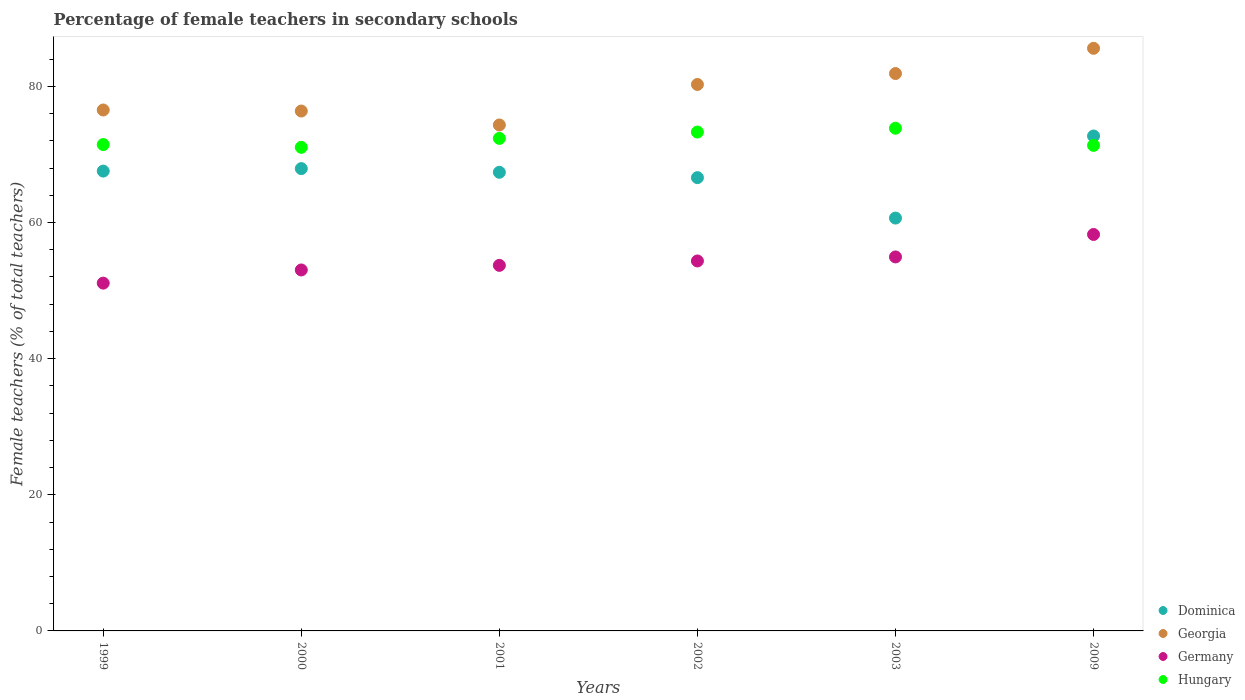How many different coloured dotlines are there?
Your answer should be compact. 4. What is the percentage of female teachers in Dominica in 2003?
Keep it short and to the point. 60.65. Across all years, what is the maximum percentage of female teachers in Germany?
Your answer should be very brief. 58.24. Across all years, what is the minimum percentage of female teachers in Germany?
Give a very brief answer. 51.09. In which year was the percentage of female teachers in Dominica minimum?
Offer a very short reply. 2003. What is the total percentage of female teachers in Germany in the graph?
Your answer should be compact. 325.37. What is the difference between the percentage of female teachers in Dominica in 2000 and that in 2009?
Provide a succinct answer. -4.79. What is the difference between the percentage of female teachers in Dominica in 2000 and the percentage of female teachers in Georgia in 2009?
Make the answer very short. -17.67. What is the average percentage of female teachers in Dominica per year?
Make the answer very short. 67.13. In the year 2001, what is the difference between the percentage of female teachers in Dominica and percentage of female teachers in Germany?
Keep it short and to the point. 13.67. In how many years, is the percentage of female teachers in Hungary greater than 76 %?
Give a very brief answer. 0. What is the ratio of the percentage of female teachers in Georgia in 2002 to that in 2003?
Ensure brevity in your answer.  0.98. What is the difference between the highest and the second highest percentage of female teachers in Georgia?
Provide a short and direct response. 3.71. What is the difference between the highest and the lowest percentage of female teachers in Georgia?
Provide a short and direct response. 11.26. Is the sum of the percentage of female teachers in Georgia in 2000 and 2003 greater than the maximum percentage of female teachers in Germany across all years?
Offer a terse response. Yes. Does the percentage of female teachers in Dominica monotonically increase over the years?
Your answer should be very brief. No. Is the percentage of female teachers in Dominica strictly greater than the percentage of female teachers in Hungary over the years?
Give a very brief answer. No. Is the percentage of female teachers in Hungary strictly less than the percentage of female teachers in Germany over the years?
Make the answer very short. No. What is the difference between two consecutive major ticks on the Y-axis?
Offer a terse response. 20. Are the values on the major ticks of Y-axis written in scientific E-notation?
Your answer should be compact. No. Does the graph contain any zero values?
Provide a succinct answer. No. Does the graph contain grids?
Your answer should be compact. No. What is the title of the graph?
Your answer should be very brief. Percentage of female teachers in secondary schools. What is the label or title of the X-axis?
Keep it short and to the point. Years. What is the label or title of the Y-axis?
Provide a succinct answer. Female teachers (% of total teachers). What is the Female teachers (% of total teachers) in Dominica in 1999?
Provide a succinct answer. 67.55. What is the Female teachers (% of total teachers) in Georgia in 1999?
Your answer should be very brief. 76.53. What is the Female teachers (% of total teachers) of Germany in 1999?
Your answer should be very brief. 51.09. What is the Female teachers (% of total teachers) of Hungary in 1999?
Give a very brief answer. 71.45. What is the Female teachers (% of total teachers) in Dominica in 2000?
Provide a short and direct response. 67.92. What is the Female teachers (% of total teachers) of Georgia in 2000?
Your answer should be compact. 76.38. What is the Female teachers (% of total teachers) of Germany in 2000?
Your answer should be very brief. 53.03. What is the Female teachers (% of total teachers) of Hungary in 2000?
Ensure brevity in your answer.  71.04. What is the Female teachers (% of total teachers) in Dominica in 2001?
Keep it short and to the point. 67.38. What is the Female teachers (% of total teachers) in Georgia in 2001?
Offer a very short reply. 74.33. What is the Female teachers (% of total teachers) of Germany in 2001?
Keep it short and to the point. 53.71. What is the Female teachers (% of total teachers) in Hungary in 2001?
Keep it short and to the point. 72.36. What is the Female teachers (% of total teachers) of Dominica in 2002?
Your answer should be compact. 66.59. What is the Female teachers (% of total teachers) of Georgia in 2002?
Your answer should be compact. 80.28. What is the Female teachers (% of total teachers) in Germany in 2002?
Make the answer very short. 54.35. What is the Female teachers (% of total teachers) of Hungary in 2002?
Your answer should be compact. 73.29. What is the Female teachers (% of total teachers) in Dominica in 2003?
Give a very brief answer. 60.65. What is the Female teachers (% of total teachers) in Georgia in 2003?
Your answer should be very brief. 81.89. What is the Female teachers (% of total teachers) of Germany in 2003?
Provide a short and direct response. 54.94. What is the Female teachers (% of total teachers) of Hungary in 2003?
Offer a terse response. 73.85. What is the Female teachers (% of total teachers) of Dominica in 2009?
Provide a short and direct response. 72.71. What is the Female teachers (% of total teachers) of Georgia in 2009?
Ensure brevity in your answer.  85.59. What is the Female teachers (% of total teachers) in Germany in 2009?
Your response must be concise. 58.24. What is the Female teachers (% of total teachers) in Hungary in 2009?
Make the answer very short. 71.33. Across all years, what is the maximum Female teachers (% of total teachers) in Dominica?
Make the answer very short. 72.71. Across all years, what is the maximum Female teachers (% of total teachers) of Georgia?
Your answer should be very brief. 85.59. Across all years, what is the maximum Female teachers (% of total teachers) of Germany?
Keep it short and to the point. 58.24. Across all years, what is the maximum Female teachers (% of total teachers) in Hungary?
Ensure brevity in your answer.  73.85. Across all years, what is the minimum Female teachers (% of total teachers) in Dominica?
Provide a succinct answer. 60.65. Across all years, what is the minimum Female teachers (% of total teachers) in Georgia?
Offer a very short reply. 74.33. Across all years, what is the minimum Female teachers (% of total teachers) in Germany?
Keep it short and to the point. 51.09. Across all years, what is the minimum Female teachers (% of total teachers) of Hungary?
Ensure brevity in your answer.  71.04. What is the total Female teachers (% of total teachers) in Dominica in the graph?
Provide a succinct answer. 402.81. What is the total Female teachers (% of total teachers) in Georgia in the graph?
Make the answer very short. 475. What is the total Female teachers (% of total teachers) in Germany in the graph?
Your answer should be compact. 325.37. What is the total Female teachers (% of total teachers) of Hungary in the graph?
Offer a terse response. 433.33. What is the difference between the Female teachers (% of total teachers) of Dominica in 1999 and that in 2000?
Offer a very short reply. -0.37. What is the difference between the Female teachers (% of total teachers) in Georgia in 1999 and that in 2000?
Your response must be concise. 0.15. What is the difference between the Female teachers (% of total teachers) of Germany in 1999 and that in 2000?
Keep it short and to the point. -1.93. What is the difference between the Female teachers (% of total teachers) in Hungary in 1999 and that in 2000?
Your response must be concise. 0.41. What is the difference between the Female teachers (% of total teachers) in Dominica in 1999 and that in 2001?
Your response must be concise. 0.17. What is the difference between the Female teachers (% of total teachers) in Georgia in 1999 and that in 2001?
Your answer should be compact. 2.2. What is the difference between the Female teachers (% of total teachers) in Germany in 1999 and that in 2001?
Provide a short and direct response. -2.61. What is the difference between the Female teachers (% of total teachers) of Hungary in 1999 and that in 2001?
Provide a short and direct response. -0.91. What is the difference between the Female teachers (% of total teachers) in Dominica in 1999 and that in 2002?
Your answer should be very brief. 0.96. What is the difference between the Female teachers (% of total teachers) in Georgia in 1999 and that in 2002?
Make the answer very short. -3.75. What is the difference between the Female teachers (% of total teachers) of Germany in 1999 and that in 2002?
Offer a very short reply. -3.26. What is the difference between the Female teachers (% of total teachers) of Hungary in 1999 and that in 2002?
Give a very brief answer. -1.84. What is the difference between the Female teachers (% of total teachers) of Dominica in 1999 and that in 2003?
Your answer should be compact. 6.9. What is the difference between the Female teachers (% of total teachers) of Georgia in 1999 and that in 2003?
Offer a very short reply. -5.35. What is the difference between the Female teachers (% of total teachers) of Germany in 1999 and that in 2003?
Offer a terse response. -3.85. What is the difference between the Female teachers (% of total teachers) of Hungary in 1999 and that in 2003?
Provide a short and direct response. -2.4. What is the difference between the Female teachers (% of total teachers) in Dominica in 1999 and that in 2009?
Ensure brevity in your answer.  -5.16. What is the difference between the Female teachers (% of total teachers) of Georgia in 1999 and that in 2009?
Give a very brief answer. -9.06. What is the difference between the Female teachers (% of total teachers) of Germany in 1999 and that in 2009?
Provide a short and direct response. -7.15. What is the difference between the Female teachers (% of total teachers) of Hungary in 1999 and that in 2009?
Your answer should be compact. 0.12. What is the difference between the Female teachers (% of total teachers) in Dominica in 2000 and that in 2001?
Ensure brevity in your answer.  0.54. What is the difference between the Female teachers (% of total teachers) in Georgia in 2000 and that in 2001?
Your answer should be compact. 2.05. What is the difference between the Female teachers (% of total teachers) in Germany in 2000 and that in 2001?
Make the answer very short. -0.68. What is the difference between the Female teachers (% of total teachers) in Hungary in 2000 and that in 2001?
Provide a succinct answer. -1.31. What is the difference between the Female teachers (% of total teachers) in Dominica in 2000 and that in 2002?
Your answer should be compact. 1.33. What is the difference between the Female teachers (% of total teachers) of Georgia in 2000 and that in 2002?
Make the answer very short. -3.91. What is the difference between the Female teachers (% of total teachers) of Germany in 2000 and that in 2002?
Offer a terse response. -1.32. What is the difference between the Female teachers (% of total teachers) in Hungary in 2000 and that in 2002?
Keep it short and to the point. -2.25. What is the difference between the Female teachers (% of total teachers) in Dominica in 2000 and that in 2003?
Ensure brevity in your answer.  7.27. What is the difference between the Female teachers (% of total teachers) in Georgia in 2000 and that in 2003?
Ensure brevity in your answer.  -5.51. What is the difference between the Female teachers (% of total teachers) in Germany in 2000 and that in 2003?
Offer a very short reply. -1.92. What is the difference between the Female teachers (% of total teachers) of Hungary in 2000 and that in 2003?
Provide a succinct answer. -2.81. What is the difference between the Female teachers (% of total teachers) of Dominica in 2000 and that in 2009?
Offer a very short reply. -4.79. What is the difference between the Female teachers (% of total teachers) of Georgia in 2000 and that in 2009?
Your answer should be very brief. -9.22. What is the difference between the Female teachers (% of total teachers) in Germany in 2000 and that in 2009?
Your answer should be very brief. -5.22. What is the difference between the Female teachers (% of total teachers) of Hungary in 2000 and that in 2009?
Make the answer very short. -0.29. What is the difference between the Female teachers (% of total teachers) in Dominica in 2001 and that in 2002?
Provide a short and direct response. 0.79. What is the difference between the Female teachers (% of total teachers) in Georgia in 2001 and that in 2002?
Offer a terse response. -5.95. What is the difference between the Female teachers (% of total teachers) in Germany in 2001 and that in 2002?
Your answer should be compact. -0.65. What is the difference between the Female teachers (% of total teachers) in Hungary in 2001 and that in 2002?
Provide a short and direct response. -0.93. What is the difference between the Female teachers (% of total teachers) in Dominica in 2001 and that in 2003?
Your answer should be very brief. 6.73. What is the difference between the Female teachers (% of total teachers) of Georgia in 2001 and that in 2003?
Offer a terse response. -7.55. What is the difference between the Female teachers (% of total teachers) of Germany in 2001 and that in 2003?
Offer a terse response. -1.24. What is the difference between the Female teachers (% of total teachers) in Hungary in 2001 and that in 2003?
Make the answer very short. -1.49. What is the difference between the Female teachers (% of total teachers) in Dominica in 2001 and that in 2009?
Provide a succinct answer. -5.33. What is the difference between the Female teachers (% of total teachers) in Georgia in 2001 and that in 2009?
Offer a very short reply. -11.26. What is the difference between the Female teachers (% of total teachers) of Germany in 2001 and that in 2009?
Keep it short and to the point. -4.54. What is the difference between the Female teachers (% of total teachers) in Hungary in 2001 and that in 2009?
Your answer should be compact. 1.03. What is the difference between the Female teachers (% of total teachers) of Dominica in 2002 and that in 2003?
Make the answer very short. 5.94. What is the difference between the Female teachers (% of total teachers) of Georgia in 2002 and that in 2003?
Provide a short and direct response. -1.6. What is the difference between the Female teachers (% of total teachers) of Germany in 2002 and that in 2003?
Provide a succinct answer. -0.59. What is the difference between the Female teachers (% of total teachers) in Hungary in 2002 and that in 2003?
Your response must be concise. -0.56. What is the difference between the Female teachers (% of total teachers) of Dominica in 2002 and that in 2009?
Ensure brevity in your answer.  -6.12. What is the difference between the Female teachers (% of total teachers) of Georgia in 2002 and that in 2009?
Ensure brevity in your answer.  -5.31. What is the difference between the Female teachers (% of total teachers) in Germany in 2002 and that in 2009?
Keep it short and to the point. -3.89. What is the difference between the Female teachers (% of total teachers) of Hungary in 2002 and that in 2009?
Your answer should be very brief. 1.96. What is the difference between the Female teachers (% of total teachers) in Dominica in 2003 and that in 2009?
Offer a very short reply. -12.06. What is the difference between the Female teachers (% of total teachers) of Georgia in 2003 and that in 2009?
Provide a succinct answer. -3.71. What is the difference between the Female teachers (% of total teachers) of Germany in 2003 and that in 2009?
Make the answer very short. -3.3. What is the difference between the Female teachers (% of total teachers) in Hungary in 2003 and that in 2009?
Offer a very short reply. 2.52. What is the difference between the Female teachers (% of total teachers) of Dominica in 1999 and the Female teachers (% of total teachers) of Georgia in 2000?
Offer a terse response. -8.82. What is the difference between the Female teachers (% of total teachers) in Dominica in 1999 and the Female teachers (% of total teachers) in Germany in 2000?
Make the answer very short. 14.52. What is the difference between the Female teachers (% of total teachers) in Dominica in 1999 and the Female teachers (% of total teachers) in Hungary in 2000?
Provide a succinct answer. -3.49. What is the difference between the Female teachers (% of total teachers) of Georgia in 1999 and the Female teachers (% of total teachers) of Germany in 2000?
Your response must be concise. 23.5. What is the difference between the Female teachers (% of total teachers) of Georgia in 1999 and the Female teachers (% of total teachers) of Hungary in 2000?
Provide a succinct answer. 5.49. What is the difference between the Female teachers (% of total teachers) of Germany in 1999 and the Female teachers (% of total teachers) of Hungary in 2000?
Keep it short and to the point. -19.95. What is the difference between the Female teachers (% of total teachers) in Dominica in 1999 and the Female teachers (% of total teachers) in Georgia in 2001?
Your response must be concise. -6.78. What is the difference between the Female teachers (% of total teachers) of Dominica in 1999 and the Female teachers (% of total teachers) of Germany in 2001?
Offer a very short reply. 13.85. What is the difference between the Female teachers (% of total teachers) of Dominica in 1999 and the Female teachers (% of total teachers) of Hungary in 2001?
Offer a very short reply. -4.81. What is the difference between the Female teachers (% of total teachers) of Georgia in 1999 and the Female teachers (% of total teachers) of Germany in 2001?
Your answer should be very brief. 22.83. What is the difference between the Female teachers (% of total teachers) in Georgia in 1999 and the Female teachers (% of total teachers) in Hungary in 2001?
Give a very brief answer. 4.17. What is the difference between the Female teachers (% of total teachers) in Germany in 1999 and the Female teachers (% of total teachers) in Hungary in 2001?
Ensure brevity in your answer.  -21.26. What is the difference between the Female teachers (% of total teachers) of Dominica in 1999 and the Female teachers (% of total teachers) of Georgia in 2002?
Your answer should be very brief. -12.73. What is the difference between the Female teachers (% of total teachers) of Dominica in 1999 and the Female teachers (% of total teachers) of Germany in 2002?
Provide a short and direct response. 13.2. What is the difference between the Female teachers (% of total teachers) of Dominica in 1999 and the Female teachers (% of total teachers) of Hungary in 2002?
Provide a short and direct response. -5.74. What is the difference between the Female teachers (% of total teachers) of Georgia in 1999 and the Female teachers (% of total teachers) of Germany in 2002?
Offer a very short reply. 22.18. What is the difference between the Female teachers (% of total teachers) of Georgia in 1999 and the Female teachers (% of total teachers) of Hungary in 2002?
Give a very brief answer. 3.24. What is the difference between the Female teachers (% of total teachers) in Germany in 1999 and the Female teachers (% of total teachers) in Hungary in 2002?
Your response must be concise. -22.19. What is the difference between the Female teachers (% of total teachers) in Dominica in 1999 and the Female teachers (% of total teachers) in Georgia in 2003?
Offer a very short reply. -14.33. What is the difference between the Female teachers (% of total teachers) in Dominica in 1999 and the Female teachers (% of total teachers) in Germany in 2003?
Provide a short and direct response. 12.61. What is the difference between the Female teachers (% of total teachers) of Dominica in 1999 and the Female teachers (% of total teachers) of Hungary in 2003?
Offer a terse response. -6.3. What is the difference between the Female teachers (% of total teachers) of Georgia in 1999 and the Female teachers (% of total teachers) of Germany in 2003?
Make the answer very short. 21.59. What is the difference between the Female teachers (% of total teachers) in Georgia in 1999 and the Female teachers (% of total teachers) in Hungary in 2003?
Provide a succinct answer. 2.68. What is the difference between the Female teachers (% of total teachers) of Germany in 1999 and the Female teachers (% of total teachers) of Hungary in 2003?
Offer a terse response. -22.76. What is the difference between the Female teachers (% of total teachers) in Dominica in 1999 and the Female teachers (% of total teachers) in Georgia in 2009?
Keep it short and to the point. -18.04. What is the difference between the Female teachers (% of total teachers) of Dominica in 1999 and the Female teachers (% of total teachers) of Germany in 2009?
Offer a terse response. 9.31. What is the difference between the Female teachers (% of total teachers) in Dominica in 1999 and the Female teachers (% of total teachers) in Hungary in 2009?
Give a very brief answer. -3.78. What is the difference between the Female teachers (% of total teachers) of Georgia in 1999 and the Female teachers (% of total teachers) of Germany in 2009?
Give a very brief answer. 18.29. What is the difference between the Female teachers (% of total teachers) of Georgia in 1999 and the Female teachers (% of total teachers) of Hungary in 2009?
Offer a very short reply. 5.2. What is the difference between the Female teachers (% of total teachers) in Germany in 1999 and the Female teachers (% of total teachers) in Hungary in 2009?
Ensure brevity in your answer.  -20.24. What is the difference between the Female teachers (% of total teachers) in Dominica in 2000 and the Female teachers (% of total teachers) in Georgia in 2001?
Offer a very short reply. -6.41. What is the difference between the Female teachers (% of total teachers) in Dominica in 2000 and the Female teachers (% of total teachers) in Germany in 2001?
Your answer should be very brief. 14.21. What is the difference between the Female teachers (% of total teachers) of Dominica in 2000 and the Female teachers (% of total teachers) of Hungary in 2001?
Provide a short and direct response. -4.44. What is the difference between the Female teachers (% of total teachers) in Georgia in 2000 and the Female teachers (% of total teachers) in Germany in 2001?
Keep it short and to the point. 22.67. What is the difference between the Female teachers (% of total teachers) of Georgia in 2000 and the Female teachers (% of total teachers) of Hungary in 2001?
Provide a short and direct response. 4.02. What is the difference between the Female teachers (% of total teachers) of Germany in 2000 and the Female teachers (% of total teachers) of Hungary in 2001?
Keep it short and to the point. -19.33. What is the difference between the Female teachers (% of total teachers) of Dominica in 2000 and the Female teachers (% of total teachers) of Georgia in 2002?
Make the answer very short. -12.36. What is the difference between the Female teachers (% of total teachers) in Dominica in 2000 and the Female teachers (% of total teachers) in Germany in 2002?
Provide a succinct answer. 13.57. What is the difference between the Female teachers (% of total teachers) in Dominica in 2000 and the Female teachers (% of total teachers) in Hungary in 2002?
Make the answer very short. -5.37. What is the difference between the Female teachers (% of total teachers) in Georgia in 2000 and the Female teachers (% of total teachers) in Germany in 2002?
Give a very brief answer. 22.02. What is the difference between the Female teachers (% of total teachers) of Georgia in 2000 and the Female teachers (% of total teachers) of Hungary in 2002?
Provide a short and direct response. 3.09. What is the difference between the Female teachers (% of total teachers) of Germany in 2000 and the Female teachers (% of total teachers) of Hungary in 2002?
Offer a very short reply. -20.26. What is the difference between the Female teachers (% of total teachers) in Dominica in 2000 and the Female teachers (% of total teachers) in Georgia in 2003?
Provide a succinct answer. -13.97. What is the difference between the Female teachers (% of total teachers) in Dominica in 2000 and the Female teachers (% of total teachers) in Germany in 2003?
Offer a terse response. 12.97. What is the difference between the Female teachers (% of total teachers) of Dominica in 2000 and the Female teachers (% of total teachers) of Hungary in 2003?
Your answer should be compact. -5.93. What is the difference between the Female teachers (% of total teachers) in Georgia in 2000 and the Female teachers (% of total teachers) in Germany in 2003?
Offer a very short reply. 21.43. What is the difference between the Female teachers (% of total teachers) of Georgia in 2000 and the Female teachers (% of total teachers) of Hungary in 2003?
Your answer should be compact. 2.53. What is the difference between the Female teachers (% of total teachers) of Germany in 2000 and the Female teachers (% of total teachers) of Hungary in 2003?
Your response must be concise. -20.82. What is the difference between the Female teachers (% of total teachers) in Dominica in 2000 and the Female teachers (% of total teachers) in Georgia in 2009?
Your answer should be compact. -17.67. What is the difference between the Female teachers (% of total teachers) in Dominica in 2000 and the Female teachers (% of total teachers) in Germany in 2009?
Your answer should be very brief. 9.68. What is the difference between the Female teachers (% of total teachers) of Dominica in 2000 and the Female teachers (% of total teachers) of Hungary in 2009?
Give a very brief answer. -3.41. What is the difference between the Female teachers (% of total teachers) in Georgia in 2000 and the Female teachers (% of total teachers) in Germany in 2009?
Give a very brief answer. 18.13. What is the difference between the Female teachers (% of total teachers) in Georgia in 2000 and the Female teachers (% of total teachers) in Hungary in 2009?
Provide a short and direct response. 5.05. What is the difference between the Female teachers (% of total teachers) of Germany in 2000 and the Female teachers (% of total teachers) of Hungary in 2009?
Provide a succinct answer. -18.3. What is the difference between the Female teachers (% of total teachers) in Dominica in 2001 and the Female teachers (% of total teachers) in Georgia in 2002?
Give a very brief answer. -12.9. What is the difference between the Female teachers (% of total teachers) in Dominica in 2001 and the Female teachers (% of total teachers) in Germany in 2002?
Provide a succinct answer. 13.03. What is the difference between the Female teachers (% of total teachers) in Dominica in 2001 and the Female teachers (% of total teachers) in Hungary in 2002?
Keep it short and to the point. -5.91. What is the difference between the Female teachers (% of total teachers) in Georgia in 2001 and the Female teachers (% of total teachers) in Germany in 2002?
Provide a short and direct response. 19.98. What is the difference between the Female teachers (% of total teachers) in Georgia in 2001 and the Female teachers (% of total teachers) in Hungary in 2002?
Offer a very short reply. 1.04. What is the difference between the Female teachers (% of total teachers) in Germany in 2001 and the Female teachers (% of total teachers) in Hungary in 2002?
Your answer should be very brief. -19.58. What is the difference between the Female teachers (% of total teachers) of Dominica in 2001 and the Female teachers (% of total teachers) of Georgia in 2003?
Your answer should be very brief. -14.51. What is the difference between the Female teachers (% of total teachers) in Dominica in 2001 and the Female teachers (% of total teachers) in Germany in 2003?
Ensure brevity in your answer.  12.44. What is the difference between the Female teachers (% of total teachers) of Dominica in 2001 and the Female teachers (% of total teachers) of Hungary in 2003?
Your answer should be compact. -6.47. What is the difference between the Female teachers (% of total teachers) in Georgia in 2001 and the Female teachers (% of total teachers) in Germany in 2003?
Offer a very short reply. 19.39. What is the difference between the Female teachers (% of total teachers) in Georgia in 2001 and the Female teachers (% of total teachers) in Hungary in 2003?
Offer a terse response. 0.48. What is the difference between the Female teachers (% of total teachers) of Germany in 2001 and the Female teachers (% of total teachers) of Hungary in 2003?
Provide a succinct answer. -20.15. What is the difference between the Female teachers (% of total teachers) in Dominica in 2001 and the Female teachers (% of total teachers) in Georgia in 2009?
Ensure brevity in your answer.  -18.21. What is the difference between the Female teachers (% of total teachers) of Dominica in 2001 and the Female teachers (% of total teachers) of Germany in 2009?
Your response must be concise. 9.14. What is the difference between the Female teachers (% of total teachers) of Dominica in 2001 and the Female teachers (% of total teachers) of Hungary in 2009?
Give a very brief answer. -3.95. What is the difference between the Female teachers (% of total teachers) in Georgia in 2001 and the Female teachers (% of total teachers) in Germany in 2009?
Your answer should be very brief. 16.09. What is the difference between the Female teachers (% of total teachers) in Georgia in 2001 and the Female teachers (% of total teachers) in Hungary in 2009?
Offer a very short reply. 3. What is the difference between the Female teachers (% of total teachers) in Germany in 2001 and the Female teachers (% of total teachers) in Hungary in 2009?
Your answer should be compact. -17.63. What is the difference between the Female teachers (% of total teachers) of Dominica in 2002 and the Female teachers (% of total teachers) of Georgia in 2003?
Offer a terse response. -15.29. What is the difference between the Female teachers (% of total teachers) of Dominica in 2002 and the Female teachers (% of total teachers) of Germany in 2003?
Your answer should be compact. 11.65. What is the difference between the Female teachers (% of total teachers) in Dominica in 2002 and the Female teachers (% of total teachers) in Hungary in 2003?
Your answer should be compact. -7.26. What is the difference between the Female teachers (% of total teachers) of Georgia in 2002 and the Female teachers (% of total teachers) of Germany in 2003?
Your answer should be compact. 25.34. What is the difference between the Female teachers (% of total teachers) in Georgia in 2002 and the Female teachers (% of total teachers) in Hungary in 2003?
Provide a succinct answer. 6.43. What is the difference between the Female teachers (% of total teachers) of Germany in 2002 and the Female teachers (% of total teachers) of Hungary in 2003?
Your response must be concise. -19.5. What is the difference between the Female teachers (% of total teachers) in Dominica in 2002 and the Female teachers (% of total teachers) in Georgia in 2009?
Keep it short and to the point. -19. What is the difference between the Female teachers (% of total teachers) of Dominica in 2002 and the Female teachers (% of total teachers) of Germany in 2009?
Ensure brevity in your answer.  8.35. What is the difference between the Female teachers (% of total teachers) of Dominica in 2002 and the Female teachers (% of total teachers) of Hungary in 2009?
Your answer should be compact. -4.74. What is the difference between the Female teachers (% of total teachers) of Georgia in 2002 and the Female teachers (% of total teachers) of Germany in 2009?
Give a very brief answer. 22.04. What is the difference between the Female teachers (% of total teachers) in Georgia in 2002 and the Female teachers (% of total teachers) in Hungary in 2009?
Provide a succinct answer. 8.95. What is the difference between the Female teachers (% of total teachers) in Germany in 2002 and the Female teachers (% of total teachers) in Hungary in 2009?
Offer a terse response. -16.98. What is the difference between the Female teachers (% of total teachers) of Dominica in 2003 and the Female teachers (% of total teachers) of Georgia in 2009?
Keep it short and to the point. -24.94. What is the difference between the Female teachers (% of total teachers) of Dominica in 2003 and the Female teachers (% of total teachers) of Germany in 2009?
Your answer should be compact. 2.41. What is the difference between the Female teachers (% of total teachers) of Dominica in 2003 and the Female teachers (% of total teachers) of Hungary in 2009?
Your response must be concise. -10.68. What is the difference between the Female teachers (% of total teachers) in Georgia in 2003 and the Female teachers (% of total teachers) in Germany in 2009?
Your answer should be compact. 23.64. What is the difference between the Female teachers (% of total teachers) of Georgia in 2003 and the Female teachers (% of total teachers) of Hungary in 2009?
Your answer should be very brief. 10.55. What is the difference between the Female teachers (% of total teachers) in Germany in 2003 and the Female teachers (% of total teachers) in Hungary in 2009?
Your answer should be compact. -16.39. What is the average Female teachers (% of total teachers) in Dominica per year?
Offer a terse response. 67.13. What is the average Female teachers (% of total teachers) of Georgia per year?
Your answer should be very brief. 79.17. What is the average Female teachers (% of total teachers) in Germany per year?
Ensure brevity in your answer.  54.23. What is the average Female teachers (% of total teachers) in Hungary per year?
Provide a short and direct response. 72.22. In the year 1999, what is the difference between the Female teachers (% of total teachers) in Dominica and Female teachers (% of total teachers) in Georgia?
Offer a terse response. -8.98. In the year 1999, what is the difference between the Female teachers (% of total teachers) of Dominica and Female teachers (% of total teachers) of Germany?
Ensure brevity in your answer.  16.46. In the year 1999, what is the difference between the Female teachers (% of total teachers) in Dominica and Female teachers (% of total teachers) in Hungary?
Provide a succinct answer. -3.9. In the year 1999, what is the difference between the Female teachers (% of total teachers) of Georgia and Female teachers (% of total teachers) of Germany?
Provide a short and direct response. 25.44. In the year 1999, what is the difference between the Female teachers (% of total teachers) in Georgia and Female teachers (% of total teachers) in Hungary?
Your response must be concise. 5.08. In the year 1999, what is the difference between the Female teachers (% of total teachers) in Germany and Female teachers (% of total teachers) in Hungary?
Your answer should be very brief. -20.36. In the year 2000, what is the difference between the Female teachers (% of total teachers) in Dominica and Female teachers (% of total teachers) in Georgia?
Your answer should be compact. -8.46. In the year 2000, what is the difference between the Female teachers (% of total teachers) of Dominica and Female teachers (% of total teachers) of Germany?
Your answer should be compact. 14.89. In the year 2000, what is the difference between the Female teachers (% of total teachers) in Dominica and Female teachers (% of total teachers) in Hungary?
Your response must be concise. -3.12. In the year 2000, what is the difference between the Female teachers (% of total teachers) in Georgia and Female teachers (% of total teachers) in Germany?
Make the answer very short. 23.35. In the year 2000, what is the difference between the Female teachers (% of total teachers) of Georgia and Female teachers (% of total teachers) of Hungary?
Give a very brief answer. 5.33. In the year 2000, what is the difference between the Female teachers (% of total teachers) in Germany and Female teachers (% of total teachers) in Hungary?
Provide a short and direct response. -18.02. In the year 2001, what is the difference between the Female teachers (% of total teachers) in Dominica and Female teachers (% of total teachers) in Georgia?
Keep it short and to the point. -6.95. In the year 2001, what is the difference between the Female teachers (% of total teachers) in Dominica and Female teachers (% of total teachers) in Germany?
Offer a terse response. 13.67. In the year 2001, what is the difference between the Female teachers (% of total teachers) of Dominica and Female teachers (% of total teachers) of Hungary?
Ensure brevity in your answer.  -4.98. In the year 2001, what is the difference between the Female teachers (% of total teachers) in Georgia and Female teachers (% of total teachers) in Germany?
Keep it short and to the point. 20.62. In the year 2001, what is the difference between the Female teachers (% of total teachers) in Georgia and Female teachers (% of total teachers) in Hungary?
Ensure brevity in your answer.  1.97. In the year 2001, what is the difference between the Female teachers (% of total teachers) in Germany and Female teachers (% of total teachers) in Hungary?
Provide a succinct answer. -18.65. In the year 2002, what is the difference between the Female teachers (% of total teachers) in Dominica and Female teachers (% of total teachers) in Georgia?
Provide a succinct answer. -13.69. In the year 2002, what is the difference between the Female teachers (% of total teachers) in Dominica and Female teachers (% of total teachers) in Germany?
Your answer should be compact. 12.24. In the year 2002, what is the difference between the Female teachers (% of total teachers) in Dominica and Female teachers (% of total teachers) in Hungary?
Provide a succinct answer. -6.7. In the year 2002, what is the difference between the Female teachers (% of total teachers) in Georgia and Female teachers (% of total teachers) in Germany?
Offer a very short reply. 25.93. In the year 2002, what is the difference between the Female teachers (% of total teachers) in Georgia and Female teachers (% of total teachers) in Hungary?
Offer a terse response. 6.99. In the year 2002, what is the difference between the Female teachers (% of total teachers) of Germany and Female teachers (% of total teachers) of Hungary?
Your answer should be compact. -18.94. In the year 2003, what is the difference between the Female teachers (% of total teachers) in Dominica and Female teachers (% of total teachers) in Georgia?
Provide a succinct answer. -21.23. In the year 2003, what is the difference between the Female teachers (% of total teachers) in Dominica and Female teachers (% of total teachers) in Germany?
Your response must be concise. 5.71. In the year 2003, what is the difference between the Female teachers (% of total teachers) of Dominica and Female teachers (% of total teachers) of Hungary?
Keep it short and to the point. -13.2. In the year 2003, what is the difference between the Female teachers (% of total teachers) in Georgia and Female teachers (% of total teachers) in Germany?
Offer a very short reply. 26.94. In the year 2003, what is the difference between the Female teachers (% of total teachers) of Georgia and Female teachers (% of total teachers) of Hungary?
Keep it short and to the point. 8.03. In the year 2003, what is the difference between the Female teachers (% of total teachers) in Germany and Female teachers (% of total teachers) in Hungary?
Your answer should be very brief. -18.91. In the year 2009, what is the difference between the Female teachers (% of total teachers) in Dominica and Female teachers (% of total teachers) in Georgia?
Provide a short and direct response. -12.88. In the year 2009, what is the difference between the Female teachers (% of total teachers) in Dominica and Female teachers (% of total teachers) in Germany?
Offer a terse response. 14.47. In the year 2009, what is the difference between the Female teachers (% of total teachers) in Dominica and Female teachers (% of total teachers) in Hungary?
Ensure brevity in your answer.  1.38. In the year 2009, what is the difference between the Female teachers (% of total teachers) in Georgia and Female teachers (% of total teachers) in Germany?
Ensure brevity in your answer.  27.35. In the year 2009, what is the difference between the Female teachers (% of total teachers) in Georgia and Female teachers (% of total teachers) in Hungary?
Keep it short and to the point. 14.26. In the year 2009, what is the difference between the Female teachers (% of total teachers) of Germany and Female teachers (% of total teachers) of Hungary?
Offer a terse response. -13.09. What is the ratio of the Female teachers (% of total teachers) of Dominica in 1999 to that in 2000?
Give a very brief answer. 0.99. What is the ratio of the Female teachers (% of total teachers) in Germany in 1999 to that in 2000?
Provide a short and direct response. 0.96. What is the ratio of the Female teachers (% of total teachers) of Georgia in 1999 to that in 2001?
Give a very brief answer. 1.03. What is the ratio of the Female teachers (% of total teachers) in Germany in 1999 to that in 2001?
Your answer should be very brief. 0.95. What is the ratio of the Female teachers (% of total teachers) in Hungary in 1999 to that in 2001?
Your answer should be compact. 0.99. What is the ratio of the Female teachers (% of total teachers) of Dominica in 1999 to that in 2002?
Your answer should be very brief. 1.01. What is the ratio of the Female teachers (% of total teachers) in Georgia in 1999 to that in 2002?
Provide a short and direct response. 0.95. What is the ratio of the Female teachers (% of total teachers) in Germany in 1999 to that in 2002?
Keep it short and to the point. 0.94. What is the ratio of the Female teachers (% of total teachers) in Hungary in 1999 to that in 2002?
Give a very brief answer. 0.97. What is the ratio of the Female teachers (% of total teachers) in Dominica in 1999 to that in 2003?
Your answer should be very brief. 1.11. What is the ratio of the Female teachers (% of total teachers) in Georgia in 1999 to that in 2003?
Offer a very short reply. 0.93. What is the ratio of the Female teachers (% of total teachers) of Germany in 1999 to that in 2003?
Offer a terse response. 0.93. What is the ratio of the Female teachers (% of total teachers) of Hungary in 1999 to that in 2003?
Provide a succinct answer. 0.97. What is the ratio of the Female teachers (% of total teachers) in Dominica in 1999 to that in 2009?
Make the answer very short. 0.93. What is the ratio of the Female teachers (% of total teachers) of Georgia in 1999 to that in 2009?
Give a very brief answer. 0.89. What is the ratio of the Female teachers (% of total teachers) of Germany in 1999 to that in 2009?
Make the answer very short. 0.88. What is the ratio of the Female teachers (% of total teachers) in Georgia in 2000 to that in 2001?
Give a very brief answer. 1.03. What is the ratio of the Female teachers (% of total teachers) of Germany in 2000 to that in 2001?
Provide a succinct answer. 0.99. What is the ratio of the Female teachers (% of total teachers) in Hungary in 2000 to that in 2001?
Provide a short and direct response. 0.98. What is the ratio of the Female teachers (% of total teachers) of Dominica in 2000 to that in 2002?
Make the answer very short. 1.02. What is the ratio of the Female teachers (% of total teachers) of Georgia in 2000 to that in 2002?
Ensure brevity in your answer.  0.95. What is the ratio of the Female teachers (% of total teachers) in Germany in 2000 to that in 2002?
Your response must be concise. 0.98. What is the ratio of the Female teachers (% of total teachers) of Hungary in 2000 to that in 2002?
Ensure brevity in your answer.  0.97. What is the ratio of the Female teachers (% of total teachers) in Dominica in 2000 to that in 2003?
Your response must be concise. 1.12. What is the ratio of the Female teachers (% of total teachers) of Georgia in 2000 to that in 2003?
Offer a very short reply. 0.93. What is the ratio of the Female teachers (% of total teachers) of Germany in 2000 to that in 2003?
Offer a terse response. 0.97. What is the ratio of the Female teachers (% of total teachers) in Hungary in 2000 to that in 2003?
Make the answer very short. 0.96. What is the ratio of the Female teachers (% of total teachers) in Dominica in 2000 to that in 2009?
Ensure brevity in your answer.  0.93. What is the ratio of the Female teachers (% of total teachers) in Georgia in 2000 to that in 2009?
Make the answer very short. 0.89. What is the ratio of the Female teachers (% of total teachers) of Germany in 2000 to that in 2009?
Your answer should be compact. 0.91. What is the ratio of the Female teachers (% of total teachers) in Hungary in 2000 to that in 2009?
Ensure brevity in your answer.  1. What is the ratio of the Female teachers (% of total teachers) of Dominica in 2001 to that in 2002?
Provide a succinct answer. 1.01. What is the ratio of the Female teachers (% of total teachers) in Georgia in 2001 to that in 2002?
Your response must be concise. 0.93. What is the ratio of the Female teachers (% of total teachers) of Germany in 2001 to that in 2002?
Ensure brevity in your answer.  0.99. What is the ratio of the Female teachers (% of total teachers) in Hungary in 2001 to that in 2002?
Ensure brevity in your answer.  0.99. What is the ratio of the Female teachers (% of total teachers) of Dominica in 2001 to that in 2003?
Provide a short and direct response. 1.11. What is the ratio of the Female teachers (% of total teachers) of Georgia in 2001 to that in 2003?
Your response must be concise. 0.91. What is the ratio of the Female teachers (% of total teachers) of Germany in 2001 to that in 2003?
Your answer should be very brief. 0.98. What is the ratio of the Female teachers (% of total teachers) in Hungary in 2001 to that in 2003?
Give a very brief answer. 0.98. What is the ratio of the Female teachers (% of total teachers) in Dominica in 2001 to that in 2009?
Provide a succinct answer. 0.93. What is the ratio of the Female teachers (% of total teachers) of Georgia in 2001 to that in 2009?
Offer a very short reply. 0.87. What is the ratio of the Female teachers (% of total teachers) of Germany in 2001 to that in 2009?
Provide a short and direct response. 0.92. What is the ratio of the Female teachers (% of total teachers) in Hungary in 2001 to that in 2009?
Offer a terse response. 1.01. What is the ratio of the Female teachers (% of total teachers) of Dominica in 2002 to that in 2003?
Keep it short and to the point. 1.1. What is the ratio of the Female teachers (% of total teachers) in Georgia in 2002 to that in 2003?
Your response must be concise. 0.98. What is the ratio of the Female teachers (% of total teachers) of Dominica in 2002 to that in 2009?
Provide a succinct answer. 0.92. What is the ratio of the Female teachers (% of total teachers) in Georgia in 2002 to that in 2009?
Your answer should be very brief. 0.94. What is the ratio of the Female teachers (% of total teachers) in Germany in 2002 to that in 2009?
Give a very brief answer. 0.93. What is the ratio of the Female teachers (% of total teachers) of Hungary in 2002 to that in 2009?
Ensure brevity in your answer.  1.03. What is the ratio of the Female teachers (% of total teachers) of Dominica in 2003 to that in 2009?
Your response must be concise. 0.83. What is the ratio of the Female teachers (% of total teachers) in Georgia in 2003 to that in 2009?
Provide a short and direct response. 0.96. What is the ratio of the Female teachers (% of total teachers) in Germany in 2003 to that in 2009?
Your response must be concise. 0.94. What is the ratio of the Female teachers (% of total teachers) of Hungary in 2003 to that in 2009?
Provide a short and direct response. 1.04. What is the difference between the highest and the second highest Female teachers (% of total teachers) in Dominica?
Offer a terse response. 4.79. What is the difference between the highest and the second highest Female teachers (% of total teachers) of Georgia?
Ensure brevity in your answer.  3.71. What is the difference between the highest and the second highest Female teachers (% of total teachers) in Germany?
Offer a very short reply. 3.3. What is the difference between the highest and the second highest Female teachers (% of total teachers) of Hungary?
Make the answer very short. 0.56. What is the difference between the highest and the lowest Female teachers (% of total teachers) of Dominica?
Make the answer very short. 12.06. What is the difference between the highest and the lowest Female teachers (% of total teachers) in Georgia?
Offer a very short reply. 11.26. What is the difference between the highest and the lowest Female teachers (% of total teachers) of Germany?
Provide a succinct answer. 7.15. What is the difference between the highest and the lowest Female teachers (% of total teachers) in Hungary?
Offer a very short reply. 2.81. 